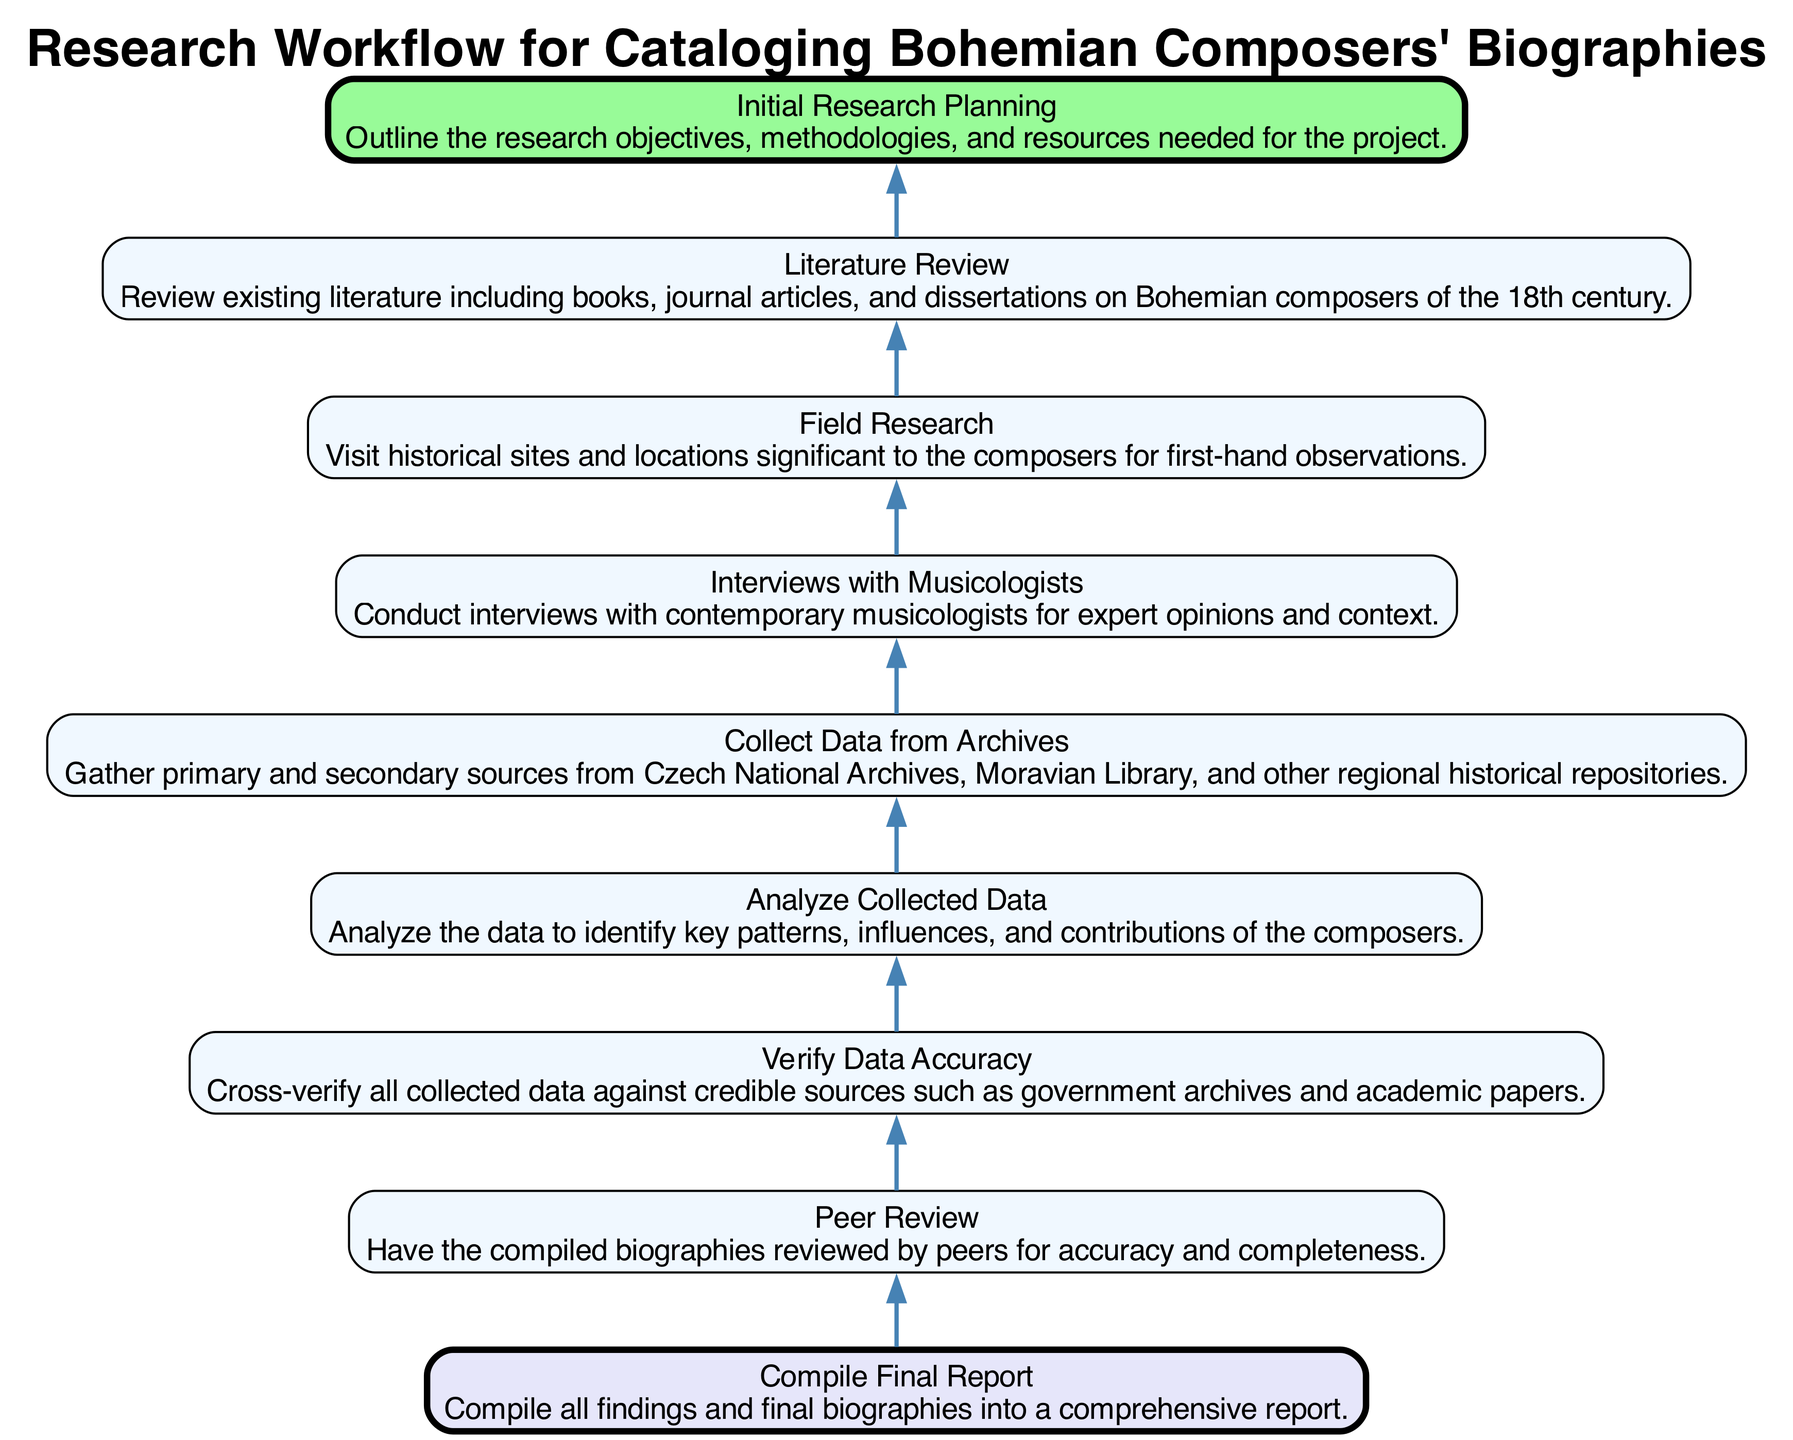What is the final step in this research workflow? The final step, represented as the top node in the diagram, is "Compile Final Report," which indicates the culmination of the research process where all biographies are compiled into a comprehensive document.
Answer: Compile Final Report How many nodes are present in the workflow? The diagram lists a total of eight nodes, each representing a different step in the research workflow. Counting the elements confirms this total.
Answer: 8 What precedes the "Peer Review" step? By examining the flow of the diagram, "Compile Final Report" is identified as the immediate step before "Peer Review," indicating that the report is completed prior to peer evaluation.
Answer: Compile Final Report What type of research is indicated before "Field Research"? "Literature Review" is the node directly preceding "Field Research," suggesting that reviewing existing literature is a necessary step before conducting field observations.
Answer: Literature Review Which step involves gathering sources? The node labeled "Collect Data from Archives" specifically mentions gathering primary and secondary sources, indicating that this is the designated step for source collection.
Answer: Collect Data from Archives How does "Analyze Collected Data" relate to "Verify Data Accuracy"? "Analyze Collected Data" occurs after "Verify Data Accuracy" in the workflow, indicating that data accuracy must first be confirmed before analyzing the patterns and contributions of the composers.
Answer: Analyze Collected Data What is the starting point of the research workflow? The starting point indicated in the diagram is "Initial Research Planning," which outlines the objectives and methodologies for the project before any data collection begins.
Answer: Initial Research Planning Which step involves collaboration with experts? The node "Interviews with Musicologists" directly addresses collaboration with contemporary musicologists, showcasing the importance of expert opinion in the research process.
Answer: Interviews with Musicologists What is the primary purpose of the "Peer Review" step? The primary purpose of "Peer Review" is to ensure the accuracy and completeness of the compiled biographies, as indicated in the description for that node.
Answer: Accuracy and completeness 